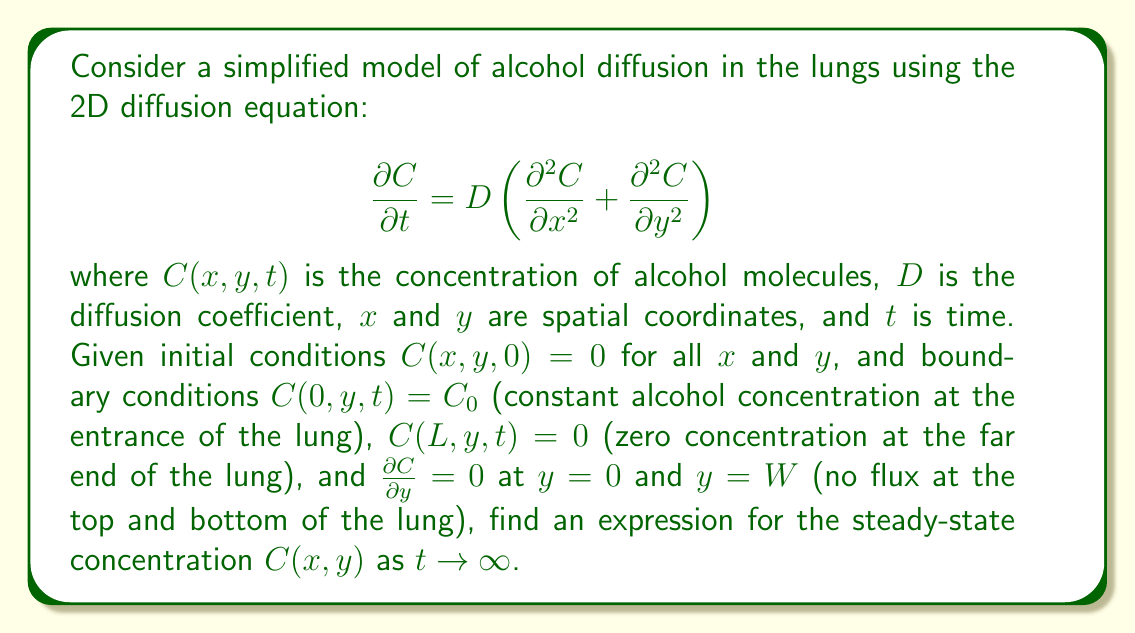Can you solve this math problem? To solve this problem, we'll follow these steps:

1) For steady-state, $\frac{\partial C}{\partial t} = 0$, so our equation becomes:

   $$D \left(\frac{\partial^2 C}{\partial x^2} + \frac{\partial^2 C}{\partial y^2}\right) = 0$$

2) Given the boundary conditions, we can use separation of variables:
   $C(x,y) = X(x)Y(y)$

3) Substituting this into our equation:

   $$X''(x)Y(y) + X(x)Y''(y) = 0$$

   $$\frac{X''(x)}{X(x)} = -\frac{Y''(y)}{Y(y)} = -k^2$$

4) This gives us two ODEs:
   
   $$X''(x) + k^2X(x) = 0$$
   $$Y''(y) - k^2Y(y) = 0$$

5) The general solutions are:
   
   $$X(x) = A\cos(kx) + B\sin(kx)$$
   $$Y(y) = Ce^{ky} + De^{-ky}$$

6) Applying the boundary conditions:

   $C(0,y) = C_0$ implies $X(0) = C_0$, so $A = C_0$
   $C(L,y) = 0$ implies $X(L) = 0$, so $C_0\cos(kL) + B\sin(kL) = 0$

   $\frac{\partial C}{\partial y} = 0$ at $y=0$ and $y=W$ implies $Y'(0) = Y'(W) = 0$

7) From the $y$ boundary conditions:

   $$kC - kD = 0 \text{ and } kCe^{kW} - kDe^{-kW} = 0$$

   This is only possible if $C = D = 0$, unless $k = 0$.

8) Therefore, $k = 0$ is the only non-trivial solution, which means $Y(y)$ is constant.

9) The solution then becomes:

   $$C(x,y) = C_0(1 - \frac{x}{L})$$

This represents a linear decrease in concentration from $C_0$ at $x=0$ to 0 at $x=L$, independent of $y$.
Answer: $C(x,y) = C_0(1 - \frac{x}{L})$ 